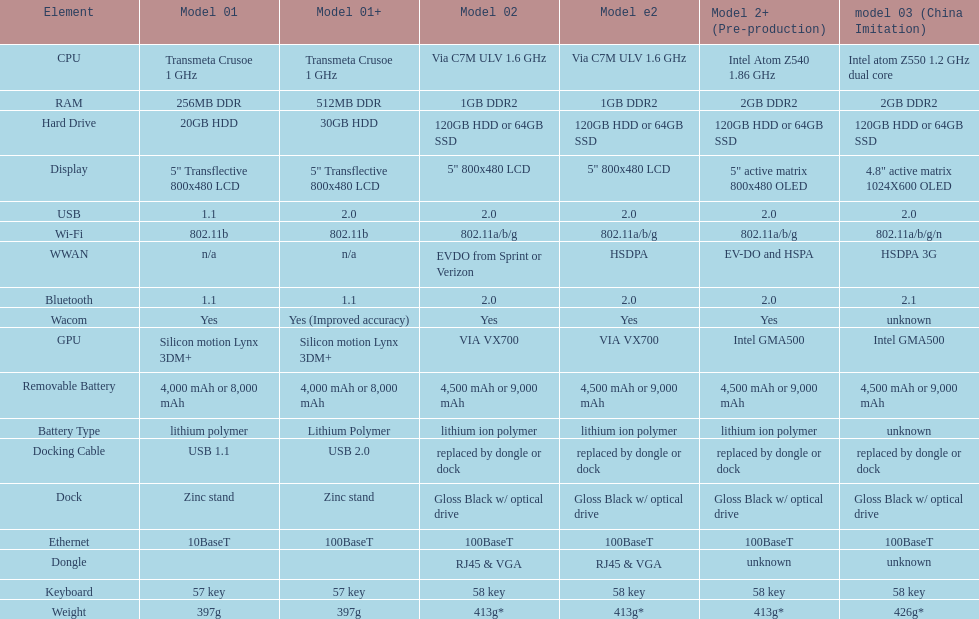Which model weighs the most, according to the table? Model 03 (china copy). 